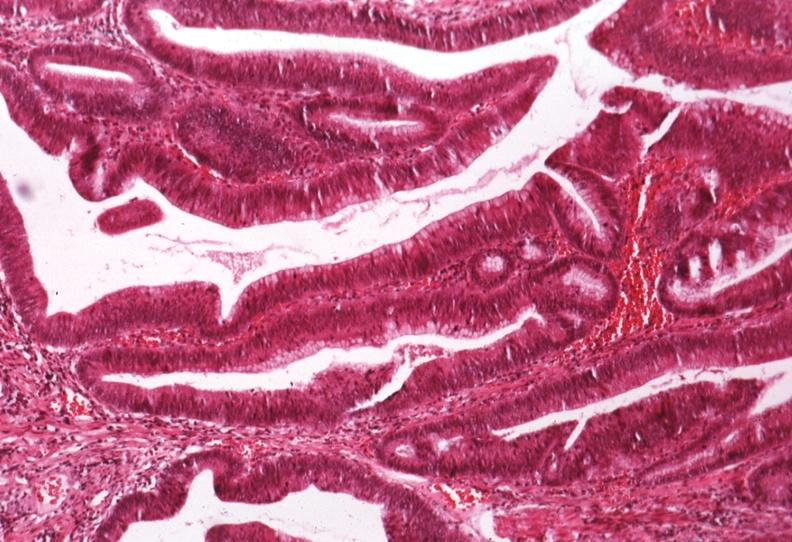s colon present?
Answer the question using a single word or phrase. Yes 